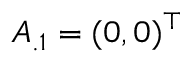Convert formula to latex. <formula><loc_0><loc_0><loc_500><loc_500>A _ { . 1 } = ( 0 , 0 ) ^ { \top }</formula> 